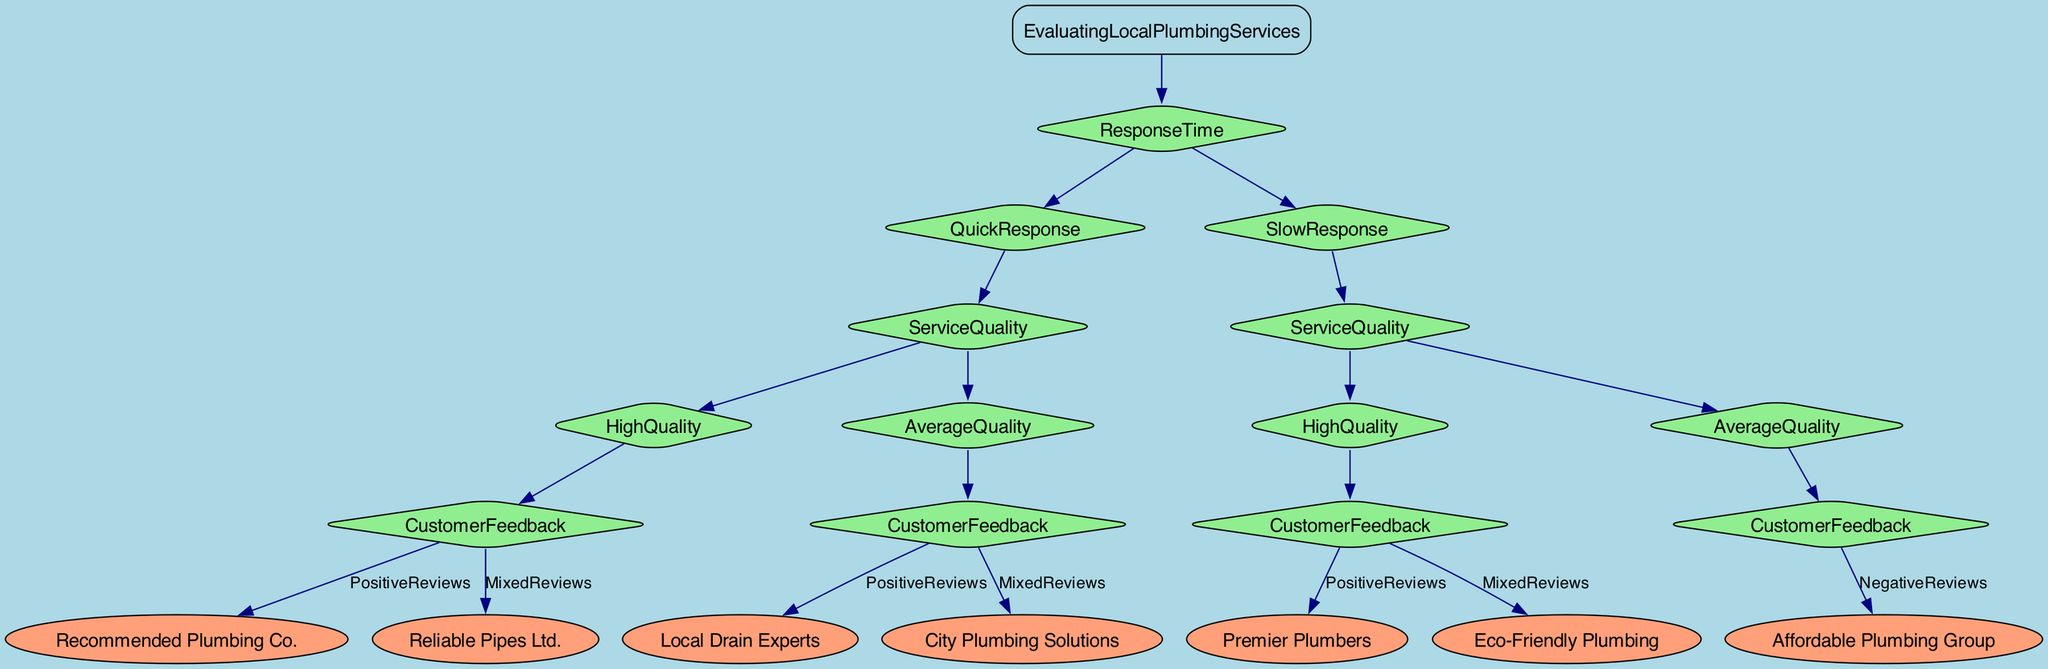What is the first decision point in the diagram? The first decision point is "ResponseTime", where the diagram branches into "QuickResponse" and "SlowResponse".
Answer: ResponseTime How many service quality options are there for quick response? For quick response, there are two service quality options: "HighQuality" and "AverageQuality".
Answer: 2 What is the service quality for the recommendation from "Premier Plumbers"? The recommendation from "Premier Plumbers" is based on "HighQuality" service, following a "SlowResponse".
Answer: HighQuality Which plumbing service is recommended for "MixedReviews" under "QuickResponse" and "AverageQuality"? The service recommended is "City Plumbing Solutions", which falls under the category of "MixedReviews" for "AverageQuality" in "QuickResponse".
Answer: City Plumbing Solutions What happens at "SlowResponse" with "AverageQuality"? At "SlowResponse" with "AverageQuality", the customer feedback results in "NegativeReviews" for "Affordable Plumbing Group".
Answer: NegativeReviews Which plumbing service is associated with "PositiveReviews" under "QuickResponse" and "HighQuality"? The service associated with "PositiveReviews" under "QuickResponse" and "HighQuality" is "Recommended Plumbing Co.".
Answer: Recommended Plumbing Co What decision leads to "Reliable Pipes Ltd."? The decision leading to "Reliable Pipes Ltd." is through "QuickResponse" and then "HighQuality" with "MixedReviews".
Answer: Reliable Pipes Ltd How many plumbing services have "PositiveReviews"? There are three plumbing services that have "PositiveReviews": "Recommended Plumbing Co.", "Local Drain Experts", and "Premier Plumbers".
Answer: 3 What is the outcome for "Affordable Plumbing Group"? The outcome for "Affordable Plumbing Group" is based on a "SlowResponse" and "AverageQuality" resulting in "NegativeReviews".
Answer: NegativeReviews 